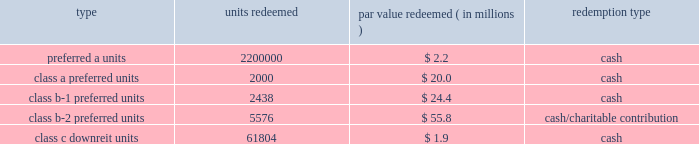Kimco realty corporation and subsidiaries notes to consolidated financial statements , continued the units consisted of ( i ) approximately 81.8 million preferred a units par value $ 1.00 per unit , which pay the holder a return of 7.0% ( 7.0 % ) per annum on the preferred a par value and are redeemable for cash by the holder at any time after one year or callable by the company any time after six months and contain a promote feature based upon an increase in net operating income of the properties capped at a 10.0% ( 10.0 % ) increase , ( ii ) 2000 class a preferred units , par value $ 10000 per unit , which pay the holder a return equal to libor plus 2.0% ( 2.0 % ) per annum on the class a preferred par value and are redeemable for cash by the holder at any time after november 30 , 2010 , ( iii ) 2627 class b-1 preferred units , par value $ 10000 per unit , which pay the holder a return equal to 7.0% ( 7.0 % ) per annum on the class b-1 preferred par value and are redeemable by the holder at any time after november 30 , 2010 , for cash or at the company 2019s option , shares of the company 2019s common stock , equal to the cash redemption amount , as defined , ( iv ) 5673 class b-2 preferred units , par value $ 10000 per unit , which pay the holder a return equal to 7.0% ( 7.0 % ) per annum on the class b-2 preferred par value and are redeemable for cash by the holder at any time after november 30 , 2010 , and ( v ) 640001 class c downreit units , valued at an issuance price of $ 30.52 per unit which pay the holder a return at a rate equal to the company 2019s common stock dividend and are redeemable by the holder at any time after november 30 , 2010 , for cash or at the company 2019s option , shares of the company 2019s common stock equal to the class c cash amount , as defined .
The following units have been redeemed as of december 31 , 2010 : redeemed par value redeemed ( in millions ) redemption type .
Noncontrolling interest relating to the remaining units was $ 110.4 million and $ 113.1 million as of december 31 , 2010 and 2009 , respectively .
During 2006 , the company acquired two shopping center properties located in bay shore and centereach , ny .
Included in noncontrolling interests was approximately $ 41.6 million , including a discount of $ 0.3 million and a fair market value adjustment of $ 3.8 million , in redeemable units ( the 201credeemable units 201d ) , issued by the company in connection with these transactions .
The prop- erties were acquired through the issuance of $ 24.2 million of redeemable units , which are redeemable at the option of the holder ; approximately $ 14.0 million of fixed rate redeemable units and the assumption of approximately $ 23.4 million of non-recourse debt .
The redeemable units consist of ( i ) 13963 class a units , par value $ 1000 per unit , which pay the holder a return of 5% ( 5 % ) per annum of the class a par value and are redeemable for cash by the holder at any time after april 3 , 2011 , or callable by the company any time after april 3 , 2016 , and ( ii ) 647758 class b units , valued at an issuance price of $ 37.24 per unit , which pay the holder a return at a rate equal to the company 2019s common stock dividend and are redeemable by the holder at any time after april 3 , 2007 , for cash or at the option of the company for common stock at a ratio of 1:1 , or callable by the company any time after april 3 , 2026 .
The company is restricted from disposing of these assets , other than through a tax free transaction , until april 2016 and april 2026 for the centereach , ny , and bay shore , ny , assets , respectively .
During 2007 , 30000 units , or $ 1.1 million par value , of theclass bunits were redeemed by the holder in cash at the option of the company .
Noncontrolling interest relating to the units was $ 40.4 million and $ 40.3 million as of december 31 , 2010 and 2009 , respectively .
Noncontrolling interests also includes 138015 convertible units issued during 2006 , by the company , which were valued at approxi- mately $ 5.3 million , including a fair market value adjustment of $ 0.3 million , related to an interest acquired in an office building located in albany , ny .
These units are redeemable at the option of the holder after one year for cash or at the option of the company for the company 2019s common stock at a ratio of 1:1 .
The holder is entitled to a distribution equal to the dividend rate of the company 2019s common stock .
The company is restricted from disposing of these assets , other than through a tax free transaction , until january 2017. .
What is the mathematical range of the five different classes of units redeemed , in millions? 
Computations: (2200000 - 2000)
Answer: 2198000.0. 